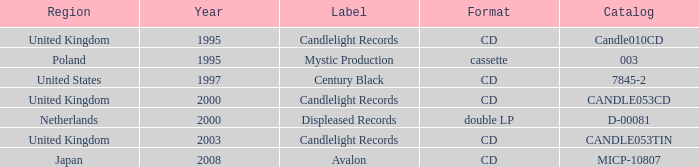What kind of format is utilized by candlelight records? CD, CD, CD. 